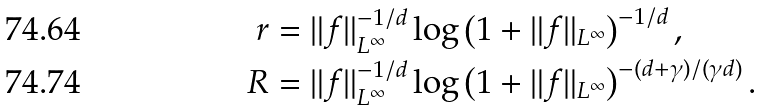<formula> <loc_0><loc_0><loc_500><loc_500>r & = \| f \| _ { L ^ { \infty } } ^ { - 1 / d } \log \left ( 1 + \| f \| _ { L ^ { \infty } } \right ) ^ { - 1 / d } , \\ R & = \| f \| _ { L ^ { \infty } } ^ { - 1 / d } \log \left ( 1 + \| f \| _ { L ^ { \infty } } \right ) ^ { - ( d + \gamma ) / ( \gamma d ) } .</formula> 